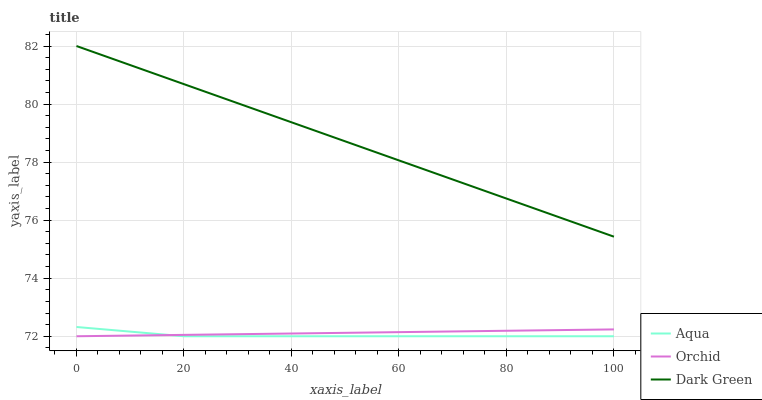Does Aqua have the minimum area under the curve?
Answer yes or no. Yes. Does Dark Green have the maximum area under the curve?
Answer yes or no. Yes. Does Orchid have the minimum area under the curve?
Answer yes or no. No. Does Orchid have the maximum area under the curve?
Answer yes or no. No. Is Dark Green the smoothest?
Answer yes or no. Yes. Is Aqua the roughest?
Answer yes or no. Yes. Is Orchid the smoothest?
Answer yes or no. No. Is Orchid the roughest?
Answer yes or no. No. Does Aqua have the lowest value?
Answer yes or no. Yes. Does Dark Green have the highest value?
Answer yes or no. Yes. Does Aqua have the highest value?
Answer yes or no. No. Is Aqua less than Dark Green?
Answer yes or no. Yes. Is Dark Green greater than Aqua?
Answer yes or no. Yes. Does Orchid intersect Aqua?
Answer yes or no. Yes. Is Orchid less than Aqua?
Answer yes or no. No. Is Orchid greater than Aqua?
Answer yes or no. No. Does Aqua intersect Dark Green?
Answer yes or no. No. 